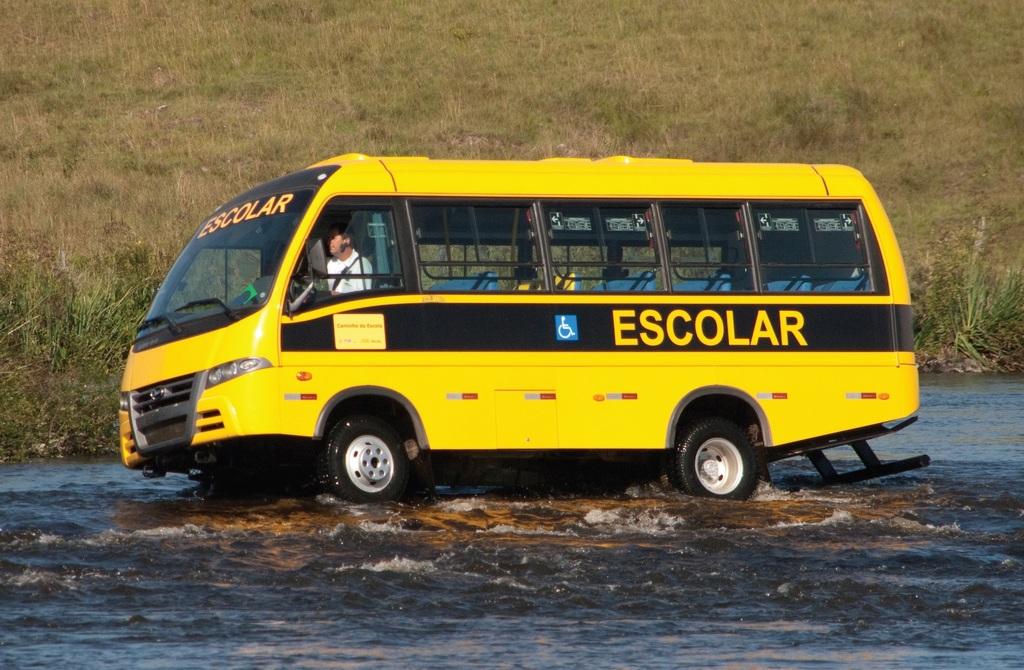What is the name on the bus?
Your response must be concise. Escolar. 